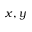<formula> <loc_0><loc_0><loc_500><loc_500>x , y</formula> 